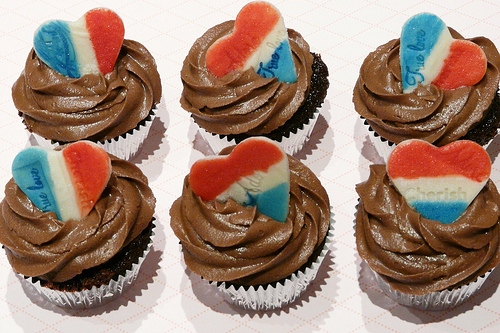<image>
Can you confirm if the cupcake is on the table? Yes. Looking at the image, I can see the cupcake is positioned on top of the table, with the table providing support. Is the heart in the chocolate frosting? Yes. The heart is contained within or inside the chocolate frosting, showing a containment relationship. Is the heart in the cupcake? Yes. The heart is contained within or inside the cupcake, showing a containment relationship. Where is the icing in relation to the cupcake? Is it in the cupcake? No. The icing is not contained within the cupcake. These objects have a different spatial relationship. 